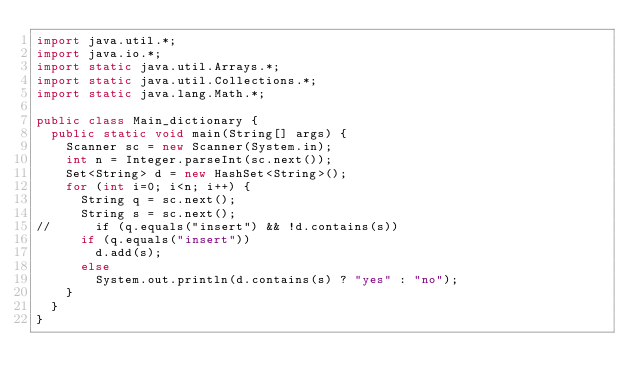<code> <loc_0><loc_0><loc_500><loc_500><_Java_>import java.util.*;
import java.io.*;
import static java.util.Arrays.*;
import static java.util.Collections.*;
import static java.lang.Math.*;

public class Main_dictionary {
  public static void main(String[] args) {
    Scanner sc = new Scanner(System.in); 
    int n = Integer.parseInt(sc.next());
    Set<String> d = new HashSet<String>();
    for (int i=0; i<n; i++) {
      String q = sc.next();
      String s = sc.next();
//      if (q.equals("insert") && !d.contains(s)) 
      if (q.equals("insert")) 
        d.add(s);
      else
        System.out.println(d.contains(s) ? "yes" : "no");
    }
  }
}</code> 